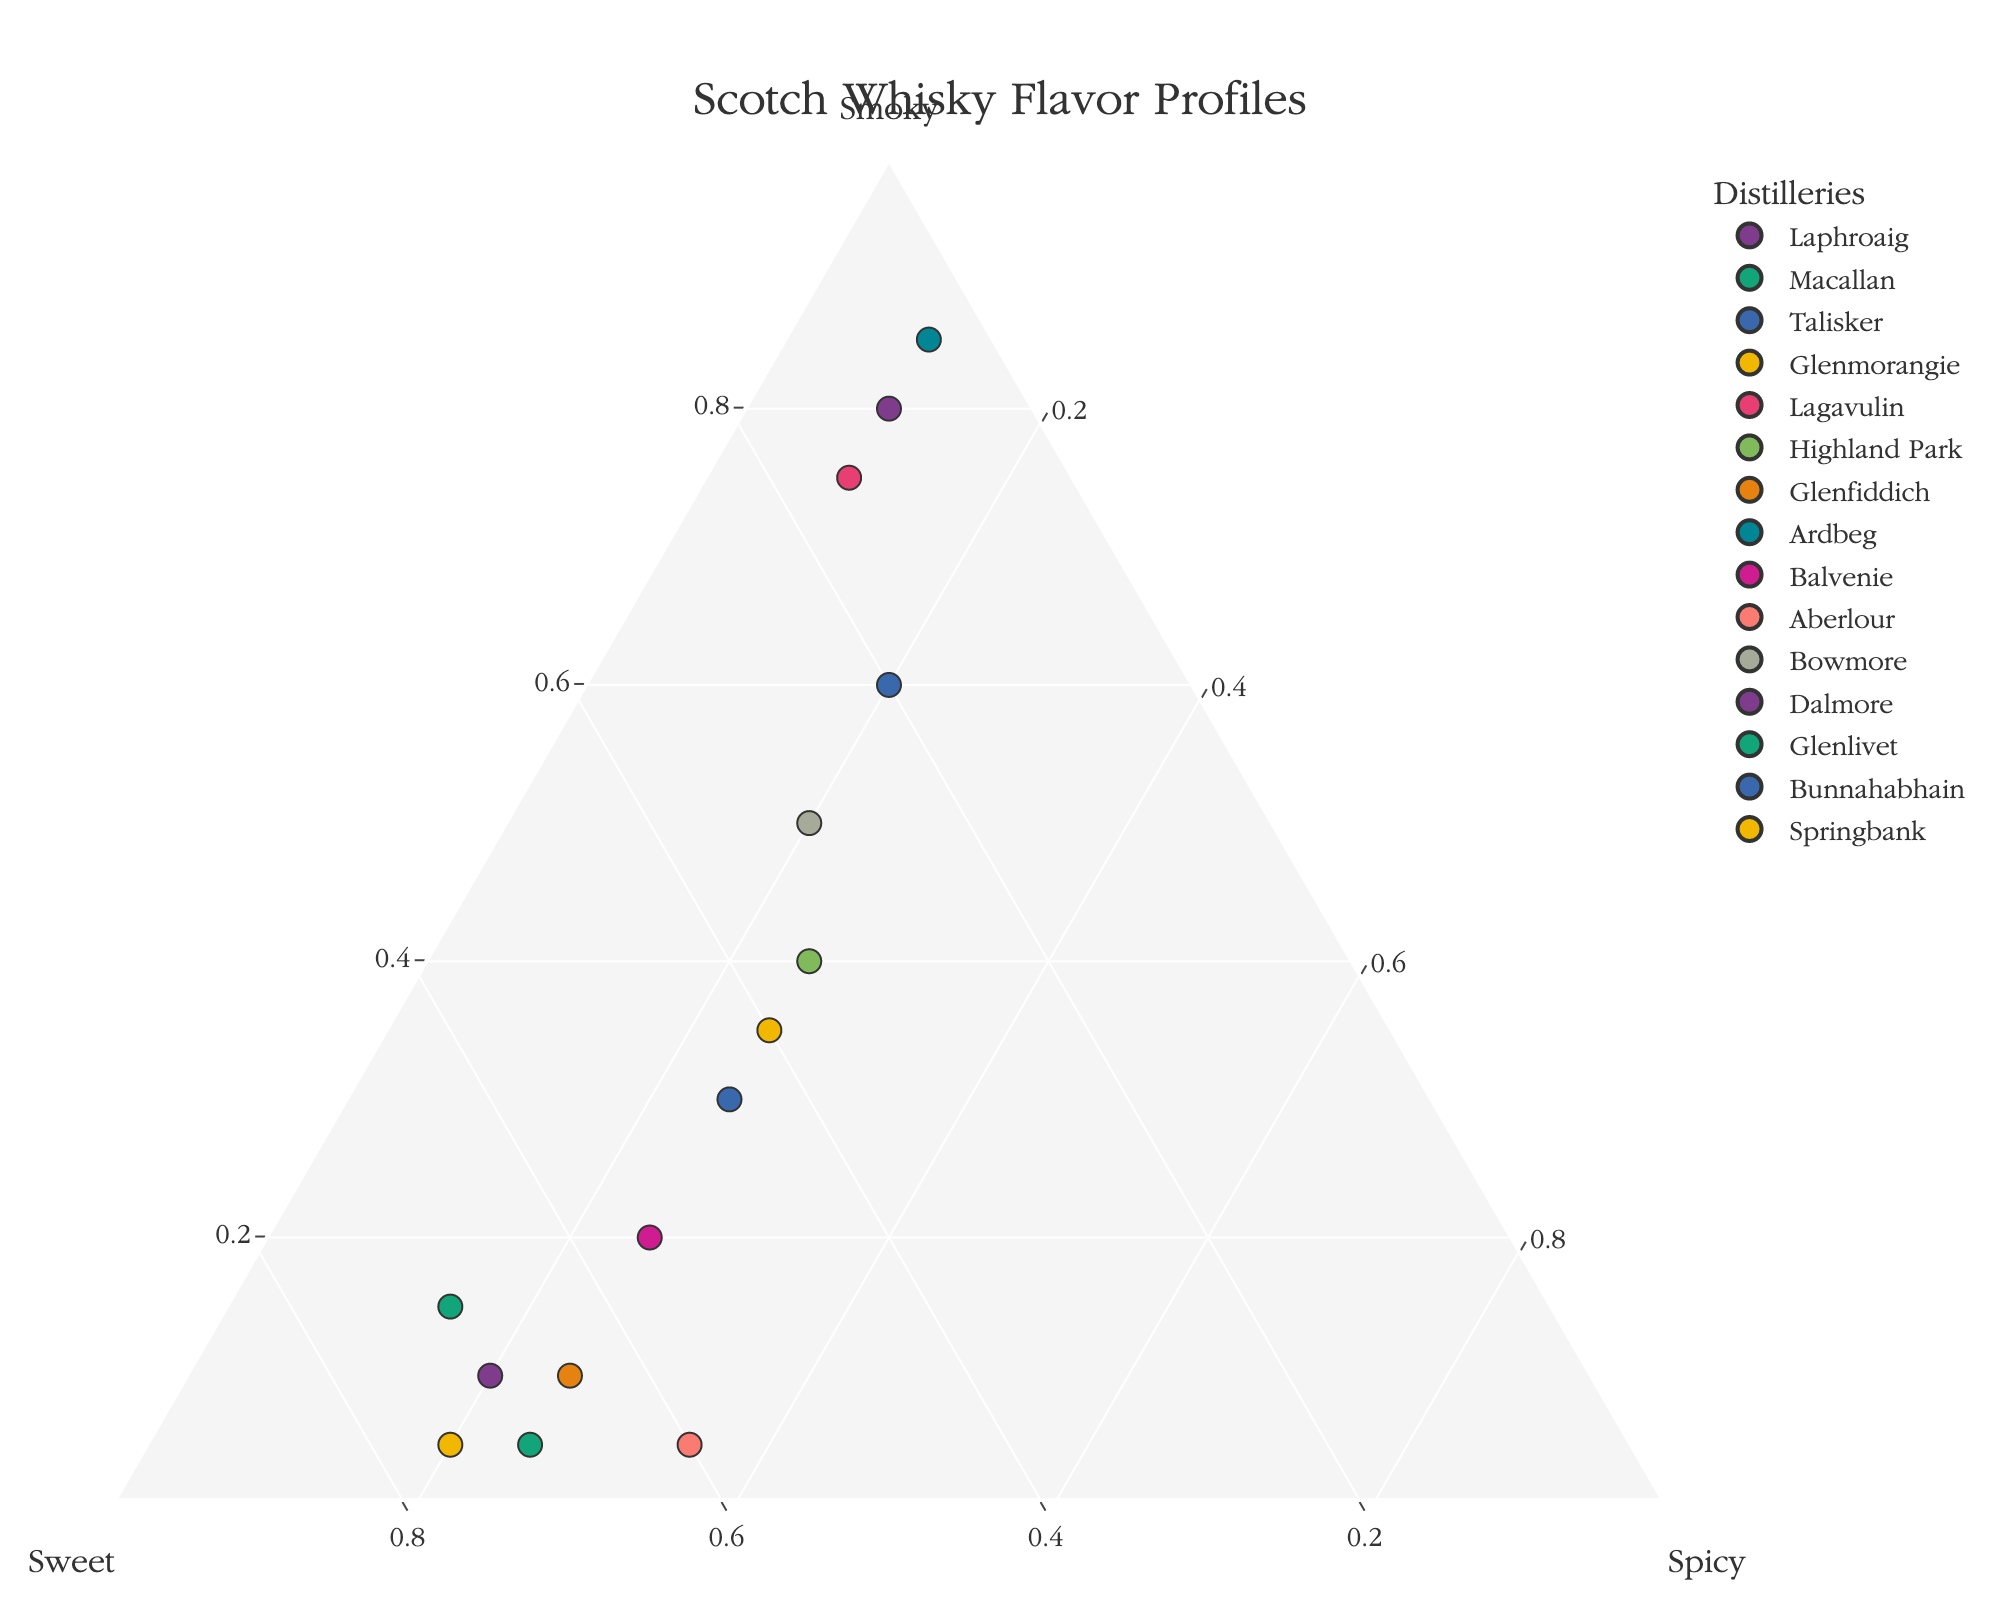What's the title of the figure? The title is displayed at the top of the figure. It indicates the main subject of the visualization.
Answer: Scotch Whisky Flavor Profiles How many distilleries are shown in the plot? Count the number of distinct points, each labeled with a distillery's name.
Answer: 15 Which distillery has the highest smokiness? Locate the point closest to the "Smoky" axis where its sum is almost entirely in the "Smoky" component.
Answer: Ardbeg Which distillery is the sweetest? Find the point that lies nearest to the "Sweet" axis, indicating a higher composition of sweetness.
Answer: Glenmorangie Which distillery showcases a balanced flavor profile among smoky, sweet, and spicy? Look for a data point approximately centered within the ternary plot, indicating a more equal distribution of all three flavors.
Answer: Highland Park How does Macallan's spiciness compare to its smokiness? Check Macallan's coordinates and evaluate the relative sizes of its "Smoky" and "Spicy" components.
Answer: Macallan's spiciness is comparable to its smokiness (both around 15) What is the sum of the sweetness levels of Glenfiddich and Dalmore? Identify the "Sweet" value for Glenfiddich and Dalmore, then add them together. Glenfiddich's sweetness is 65, Dalmore's is 70.
Answer: 135 Compare the smokiness of Laphroaig and Lagavulin. Which one is smokier? Locate the positions of Laphroaig and Lagavulin and compare their "Smoky" values.
Answer: Laphroaig Which distillery has the lowest values for both smoky and spicy flavors? Find the point closest to the intersection of the "Sweet" axis, indicating very low "Smoky" and "Spicy" values.
Answer: Glenmorangie What's the average sweetness of the distilleries from Glenmorangie, Glenfiddich, and Glenlivet? Sum the "Sweet" values of Glenmorangie (75), Glenfiddich (65), and Glenlivet (70), then divide by 3.
Answer: 70 